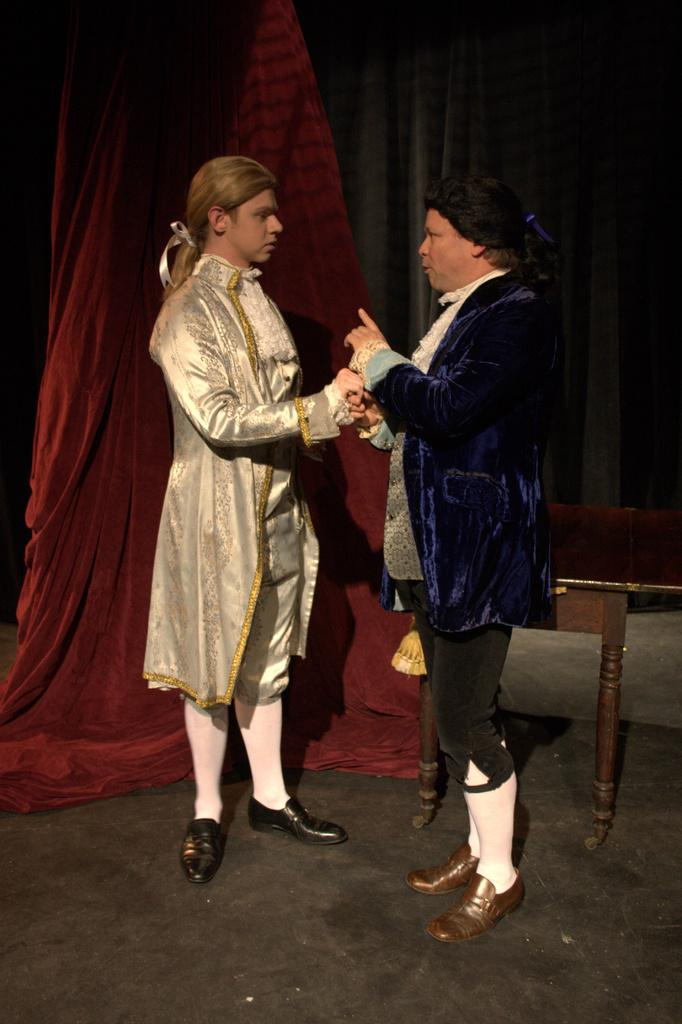How many people are present in the image? There are two people standing in the image. What is the surface beneath the people? The people are standing on a floor. What can be seen in the background of the image? There is a table and a curtain in the background of the image. What type of observation can be made about the fowl in the image? There is no fowl present in the image, so no observation can be made about it. 